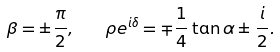<formula> <loc_0><loc_0><loc_500><loc_500>\beta = \pm \frac { \pi } { 2 } , \quad \rho e ^ { i \delta } = \mp \frac { 1 } { 4 } \tan \alpha \pm \frac { i } { 2 } .</formula> 